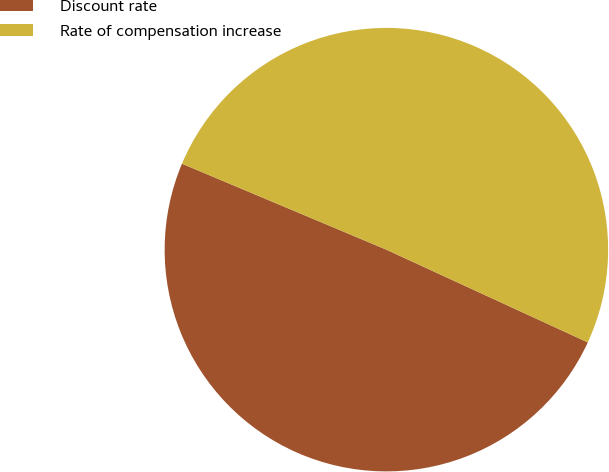Convert chart to OTSL. <chart><loc_0><loc_0><loc_500><loc_500><pie_chart><fcel>Discount rate<fcel>Rate of compensation increase<nl><fcel>49.47%<fcel>50.53%<nl></chart> 